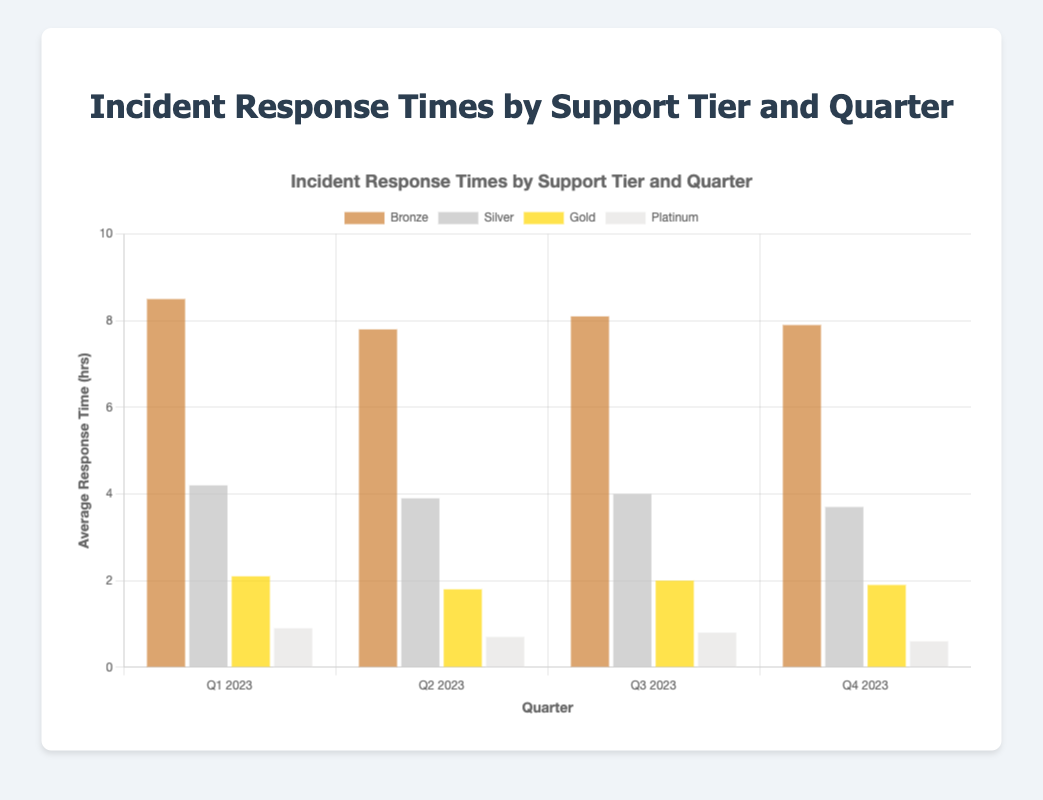Which support tier has the shortest average response time in Q1 2023? Look at the bars corresponding to Q1 2023 and compare the heights/values. The Platinum tier has the lowest bar at 0.9 hours.
Answer: Platinum How does the Bronze tier's response time change from Q1 2023 to Q4 2023? Compare the Bronze bars in Q1 and Q4. In Q1, it is 8.5 hours, and in Q4, it is 7.9 hours. The difference is 8.5 - 7.9.
Answer: Decreases by 0.6 hours Which quarter shows the greatest improvement in response time for the Silver tier compared to the previous quarter? Compare the response times of the Silver tier each quarter: Q2 improves from Q1 by 4.2 - 3.9 = 0.3 hours, Q3 improves from Q2 by 3.9 - 4.0 = -0.1 hours (no improvement), and Q4 improves from Q3 by 4.0 - 3.7 = 0.3 hours. Q2 and Q4 both show improvements of 0.3 hours, but no quarter has a greatest improvement over Q2.
Answer: Q2 2023 and Q4 2023 What is the average response time for the Gold tier across all four quarters? Sum the response times for the Gold tier across Q1 to Q4 and divide by the number of quarters: (2.1 + 1.8 + 2.0 + 1.9) / 4 = 7.8 / 4.
Answer: 1.95 hours Which quarter had the most consistent response times across all support tiers? Look at the bars for each quarter and observe the range of response times. Q4 2023 has the bars clustered most closely together, with values of 7.9, 3.7, 1.9, and 0.6. The range is 7.9 - 0.6 = 7.3 hours, which is lower compared to other quarters.
Answer: Q4 2023 For Q3 2023, how much faster was the average response time in the Platinum tier compared to the Silver tier? Compare the response times for Platinum and Silver in Q3. The Platinum tier is 0.8 hours and the Silver tier is 4.0 hours. The difference is 4.0 - 0.8.
Answer: 3.2 hours faster Which support tier shows the smallest change in response time from Q1 2023 to Q4 2023? Calculate the change for each tier: Bronze (7.9 - 8.5 = -0.6), Silver (3.7 - 4.2 = -0.5), Gold (1.9 - 2.1 = -0.2), and Platinum (0.6 - 0.9 = -0.3). The Gold tier has the smallest change of -0.2 hours.
Answer: Gold By how many hours did the Silver tier improve its response time from Q1 2023 to Q4 2023? Compare the response times of the Silver tier in Q1 and Q4. The improvement is 4.2 - 3.7.
Answer: 0.5 hours In which quarter did the Bronze tier have the fastest response time? Look at the response times for the Bronze tier across all quarters. The lowest response time is in Q2 2023 at 7.8 hours.
Answer: Q2 2023 